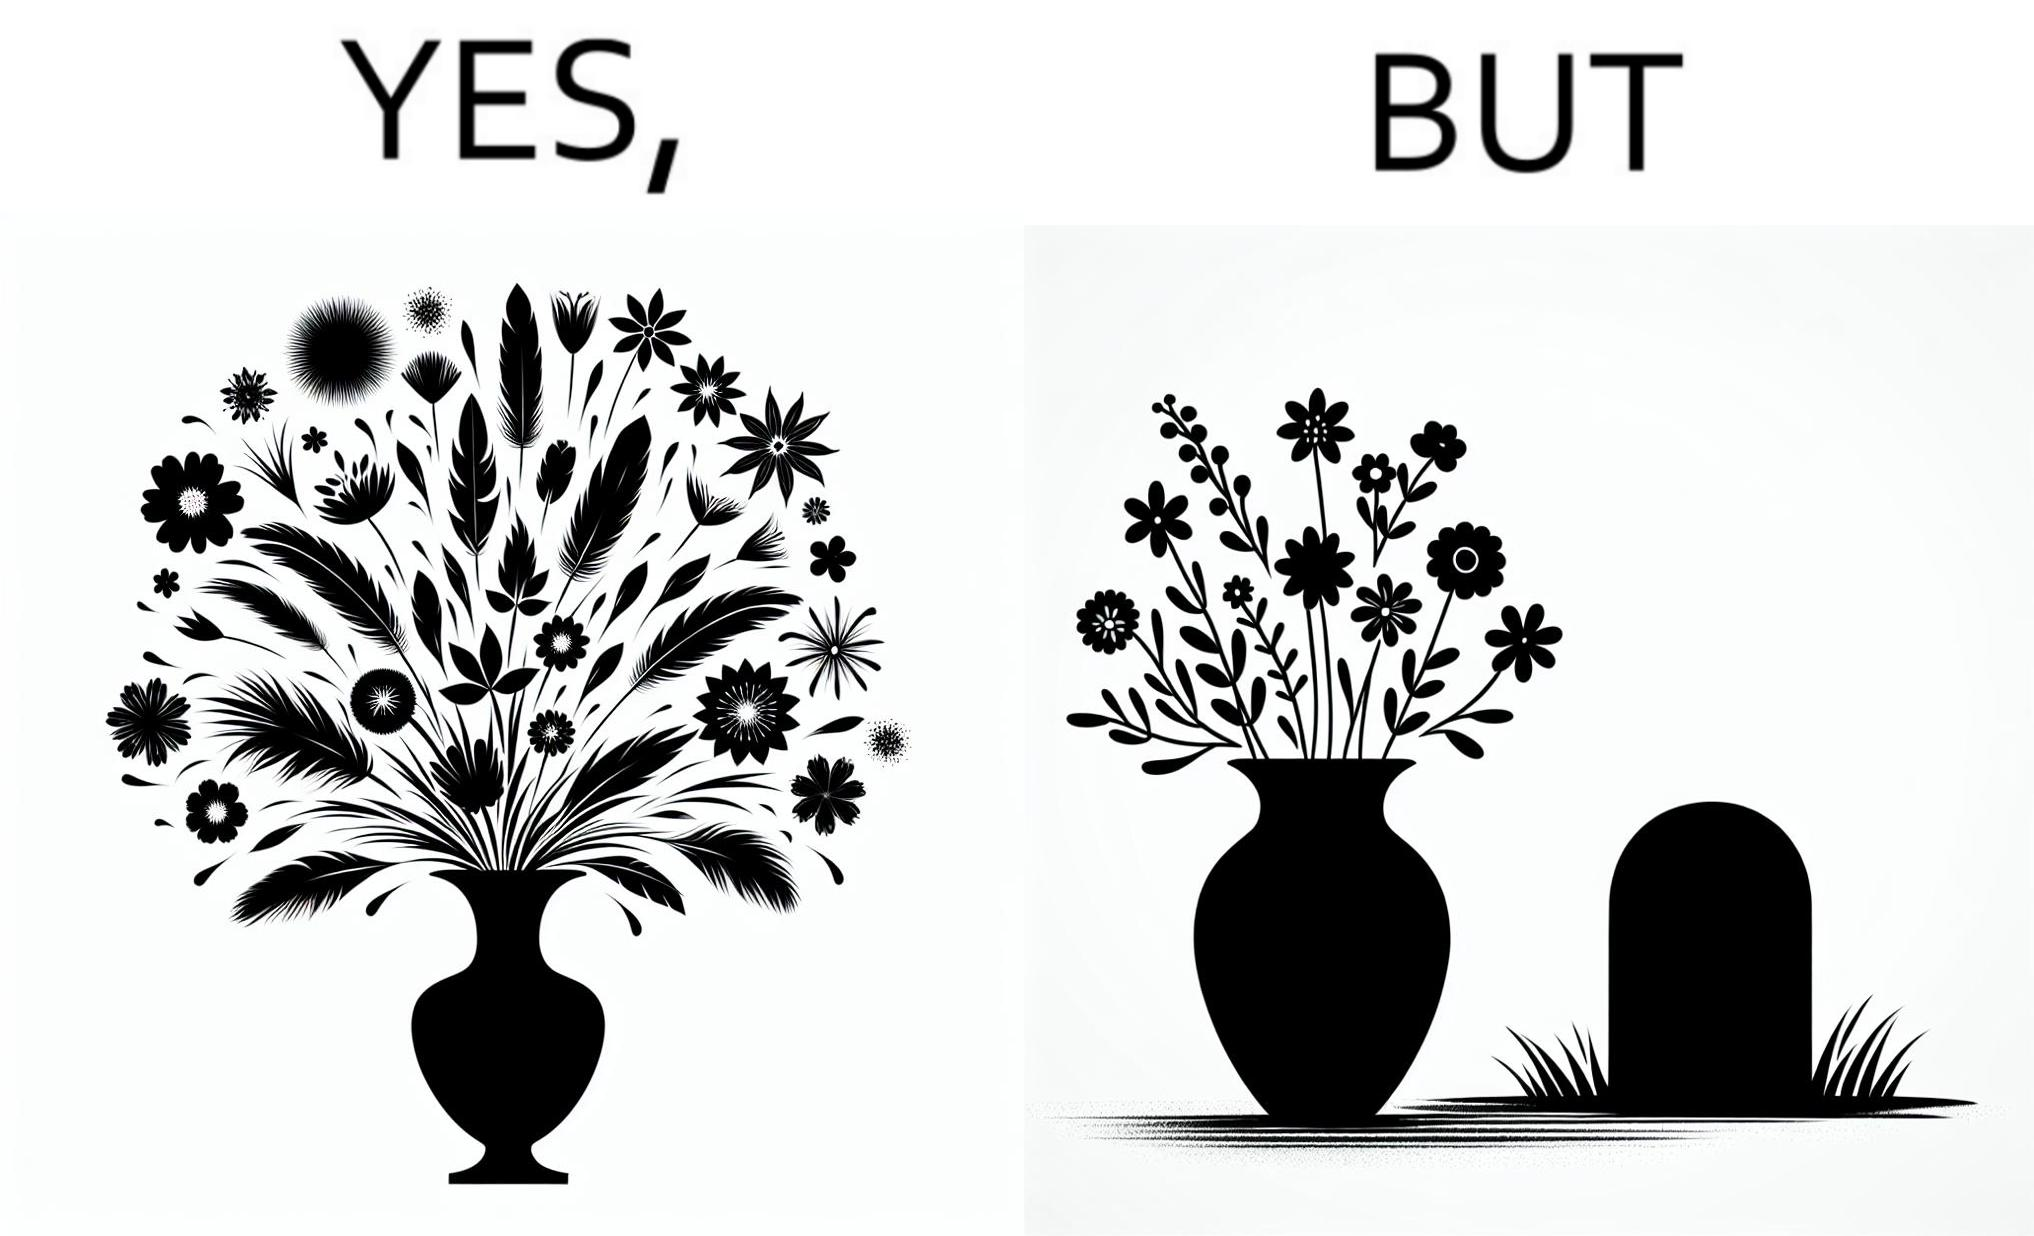Describe the contrast between the left and right parts of this image. In the left part of the image: a beautiful vase of full of different beautiful flowers In the right part of the image: a beautiful vase of full of different beautiful flowers put in front of someone's grave stone 